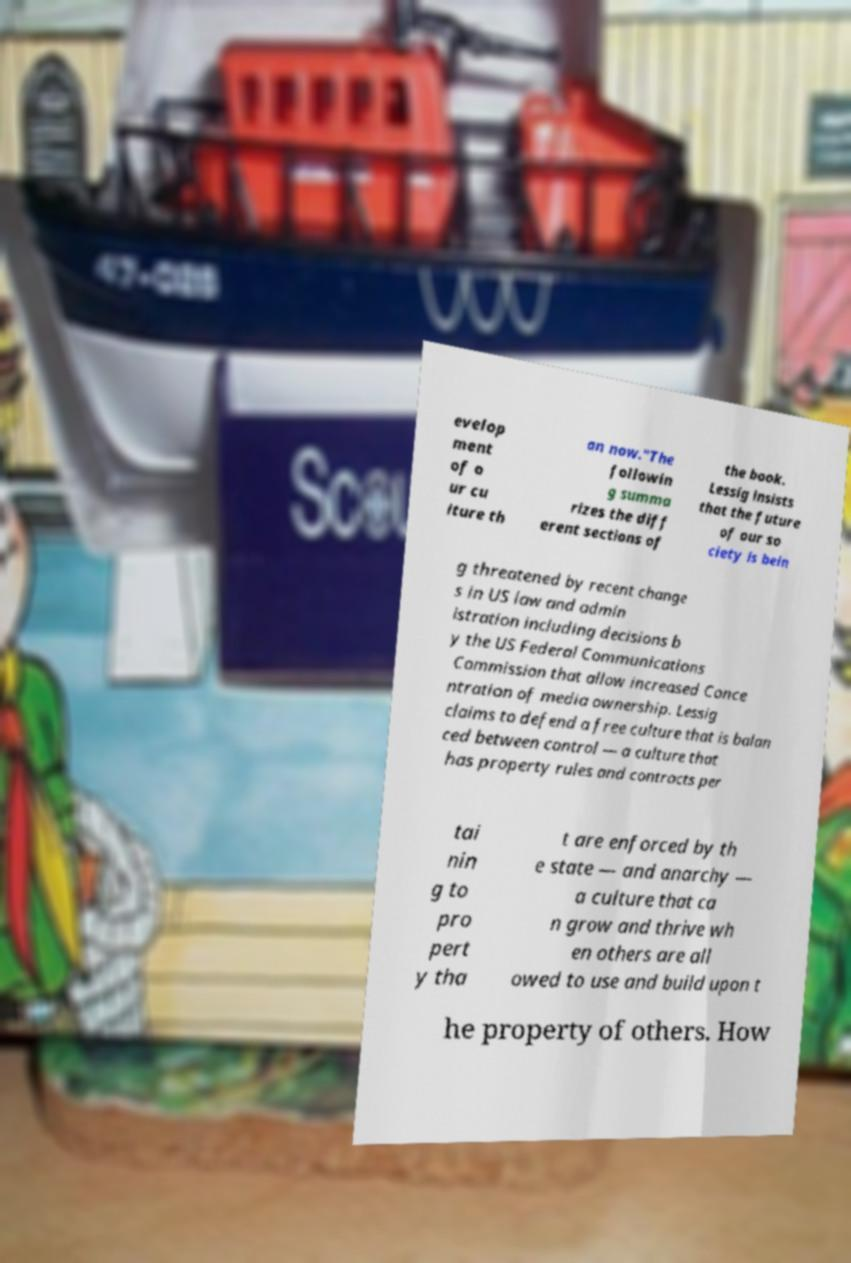Can you accurately transcribe the text from the provided image for me? evelop ment of o ur cu lture th an now."The followin g summa rizes the diff erent sections of the book. Lessig insists that the future of our so ciety is bein g threatened by recent change s in US law and admin istration including decisions b y the US Federal Communications Commission that allow increased Conce ntration of media ownership. Lessig claims to defend a free culture that is balan ced between control — a culture that has property rules and contracts per tai nin g to pro pert y tha t are enforced by th e state — and anarchy — a culture that ca n grow and thrive wh en others are all owed to use and build upon t he property of others. How 